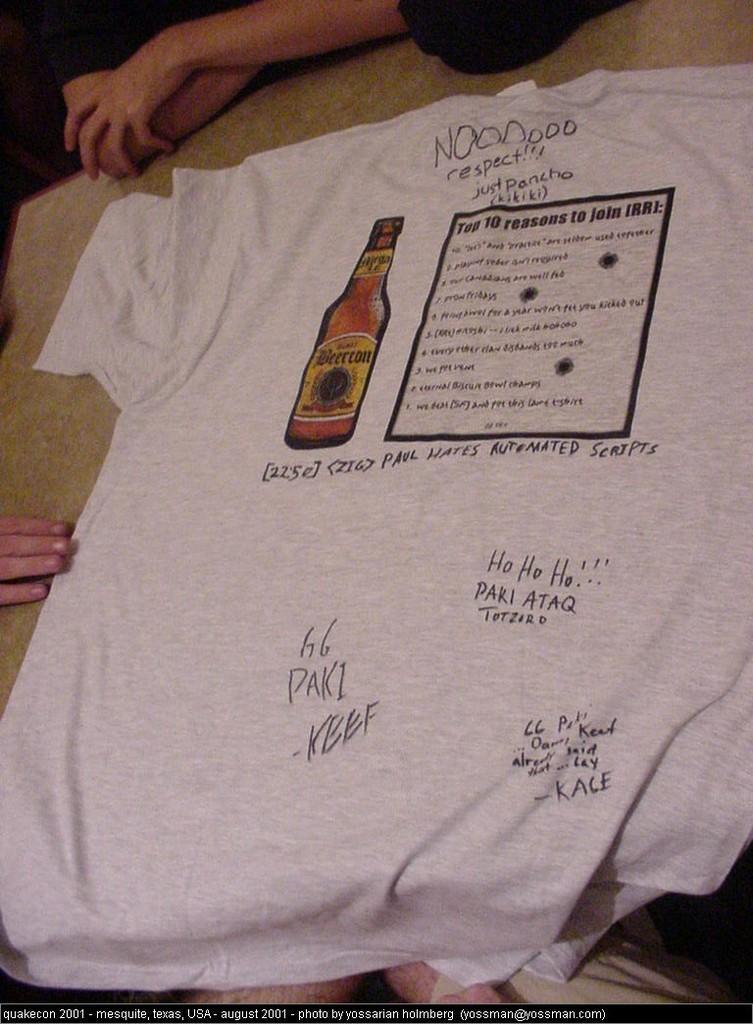Please provide a concise description of this image. In the foreground of this picture, there is a T shirt on which a bottle and a box is printed on it. In the background, we can see hands and legs of the persons. 